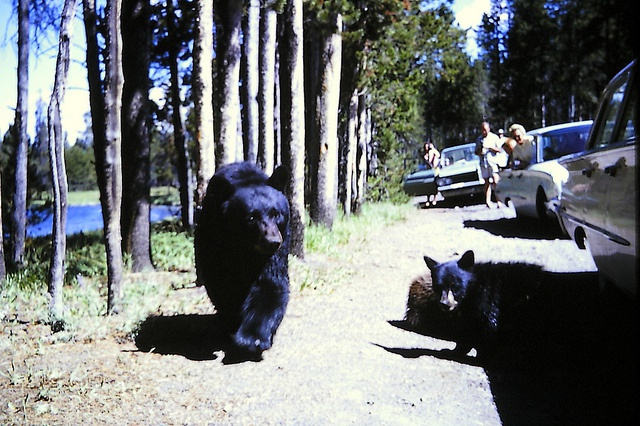Describe the objects in this image and their specific colors. I can see bear in lightblue, black, blue, navy, and lightgray tones, bear in lightblue, black, navy, blue, and lightgray tones, car in lightblue, black, and gray tones, car in lightblue, black, gray, ivory, and navy tones, and car in lightblue, black, white, and gray tones in this image. 